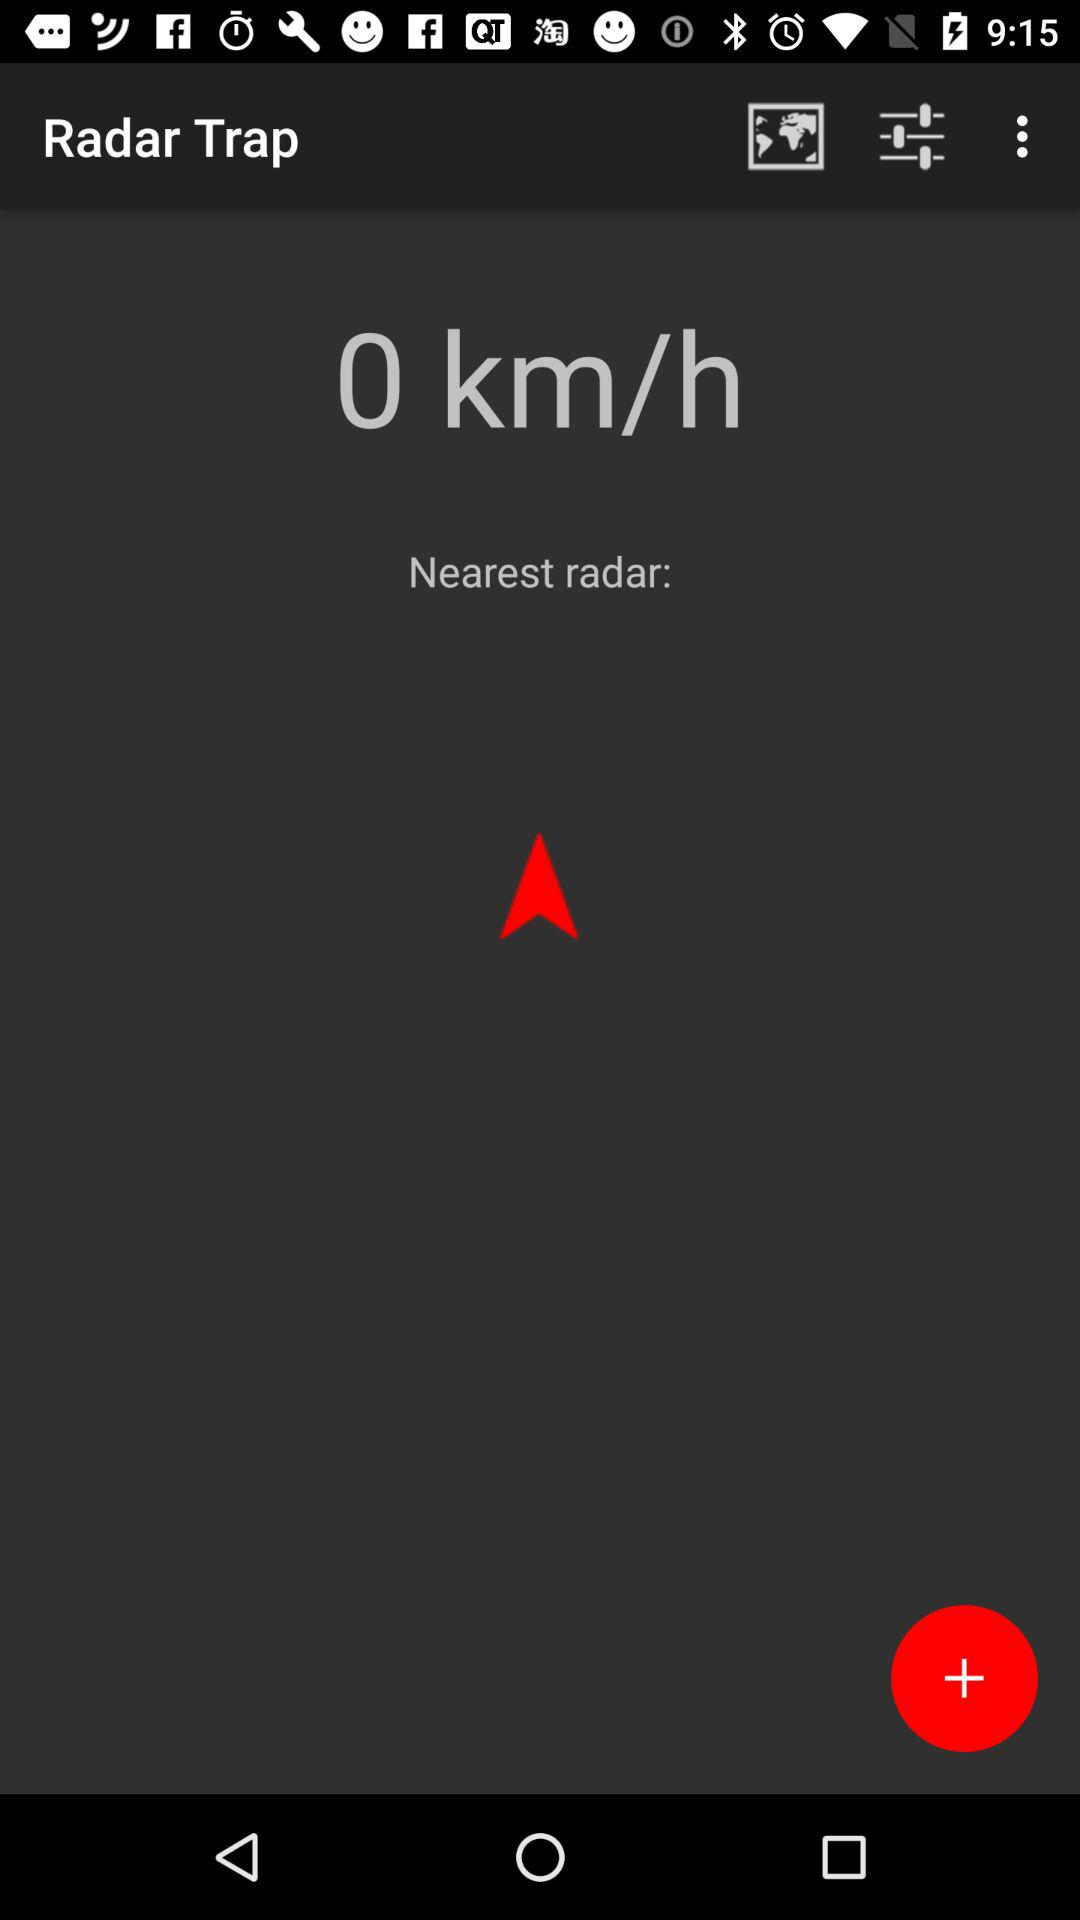What is the application name? The application name is "Radar Trap". 